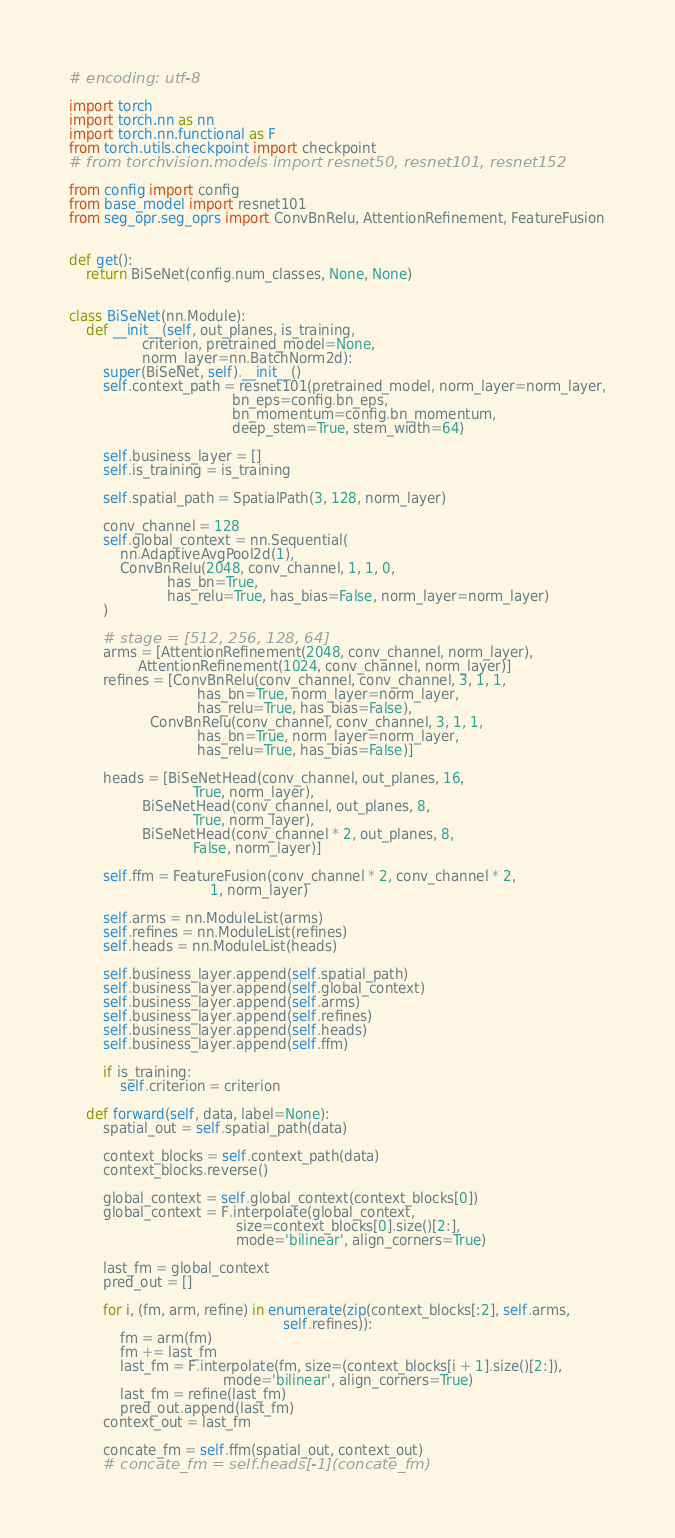<code> <loc_0><loc_0><loc_500><loc_500><_Python_># encoding: utf-8

import torch
import torch.nn as nn
import torch.nn.functional as F
from torch.utils.checkpoint import checkpoint
# from torchvision.models import resnet50, resnet101, resnet152

from config import config
from base_model import resnet101
from seg_opr.seg_oprs import ConvBnRelu, AttentionRefinement, FeatureFusion


def get():
    return BiSeNet(config.num_classes, None, None)


class BiSeNet(nn.Module):
    def __init__(self, out_planes, is_training,
                 criterion, pretrained_model=None,
                 norm_layer=nn.BatchNorm2d):
        super(BiSeNet, self).__init__()
        self.context_path = resnet101(pretrained_model, norm_layer=norm_layer,
                                      bn_eps=config.bn_eps,
                                      bn_momentum=config.bn_momentum,
                                      deep_stem=True, stem_width=64)

        self.business_layer = []
        self.is_training = is_training

        self.spatial_path = SpatialPath(3, 128, norm_layer)

        conv_channel = 128
        self.global_context = nn.Sequential(
            nn.AdaptiveAvgPool2d(1),
            ConvBnRelu(2048, conv_channel, 1, 1, 0,
                       has_bn=True,
                       has_relu=True, has_bias=False, norm_layer=norm_layer)
        )

        # stage = [512, 256, 128, 64]
        arms = [AttentionRefinement(2048, conv_channel, norm_layer),
                AttentionRefinement(1024, conv_channel, norm_layer)]
        refines = [ConvBnRelu(conv_channel, conv_channel, 3, 1, 1,
                              has_bn=True, norm_layer=norm_layer,
                              has_relu=True, has_bias=False),
                   ConvBnRelu(conv_channel, conv_channel, 3, 1, 1,
                              has_bn=True, norm_layer=norm_layer,
                              has_relu=True, has_bias=False)]

        heads = [BiSeNetHead(conv_channel, out_planes, 16,
                             True, norm_layer),
                 BiSeNetHead(conv_channel, out_planes, 8,
                             True, norm_layer),
                 BiSeNetHead(conv_channel * 2, out_planes, 8,
                             False, norm_layer)]

        self.ffm = FeatureFusion(conv_channel * 2, conv_channel * 2,
                                 1, norm_layer)

        self.arms = nn.ModuleList(arms)
        self.refines = nn.ModuleList(refines)
        self.heads = nn.ModuleList(heads)

        self.business_layer.append(self.spatial_path)
        self.business_layer.append(self.global_context)
        self.business_layer.append(self.arms)
        self.business_layer.append(self.refines)
        self.business_layer.append(self.heads)
        self.business_layer.append(self.ffm)

        if is_training:
            self.criterion = criterion

    def forward(self, data, label=None):
        spatial_out = self.spatial_path(data)

        context_blocks = self.context_path(data)
        context_blocks.reverse()

        global_context = self.global_context(context_blocks[0])
        global_context = F.interpolate(global_context,
                                       size=context_blocks[0].size()[2:],
                                       mode='bilinear', align_corners=True)

        last_fm = global_context
        pred_out = []

        for i, (fm, arm, refine) in enumerate(zip(context_blocks[:2], self.arms,
                                                  self.refines)):
            fm = arm(fm)
            fm += last_fm
            last_fm = F.interpolate(fm, size=(context_blocks[i + 1].size()[2:]),
                                    mode='bilinear', align_corners=True)
            last_fm = refine(last_fm)
            pred_out.append(last_fm)
        context_out = last_fm

        concate_fm = self.ffm(spatial_out, context_out)
        # concate_fm = self.heads[-1](concate_fm)</code> 